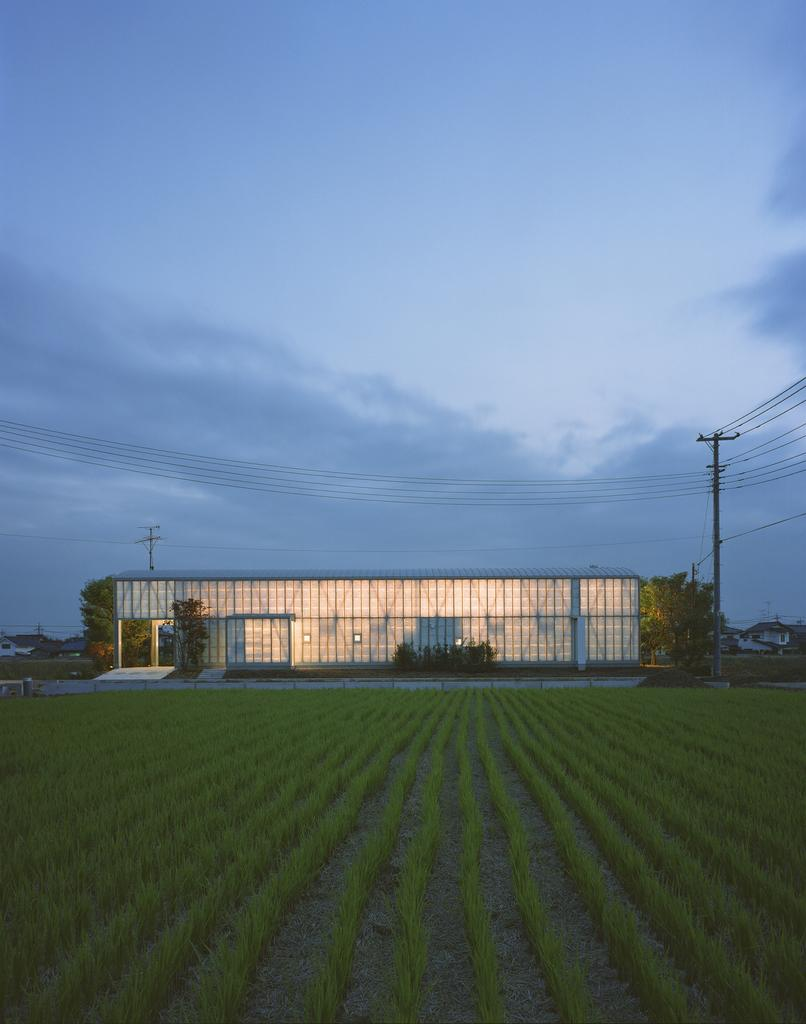What type of landscape is depicted in the image? There is a field with crops in the image. What structure can be seen in the front of the field? There is a large compartment in the front of the field. What is located beside the large compartment? There is a pole beside the large compartment. What is attached to the pole? Many wires are attached to the pole. How does the field help the achiever pay off their debt in the image? There is no mention of an achiever or debt in the image; it simply depicts a field with crops, a large compartment, a pole, and wires. 